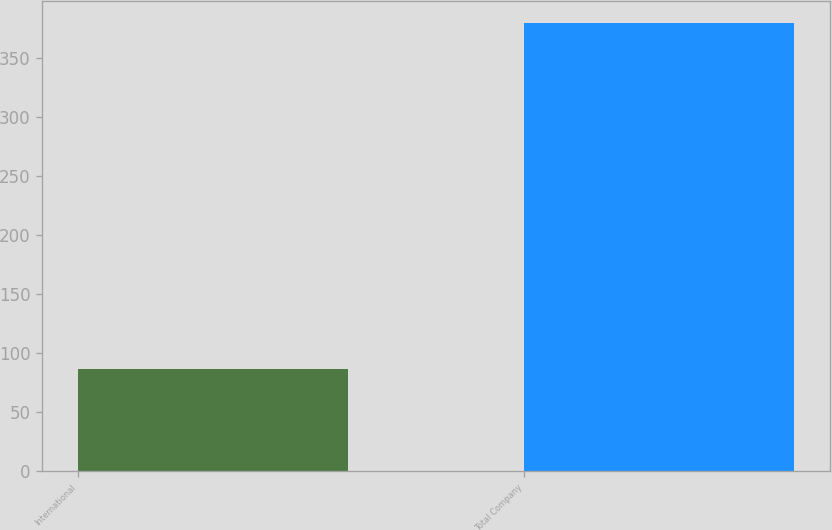<chart> <loc_0><loc_0><loc_500><loc_500><bar_chart><fcel>International<fcel>Total Company<nl><fcel>86.6<fcel>379.2<nl></chart> 